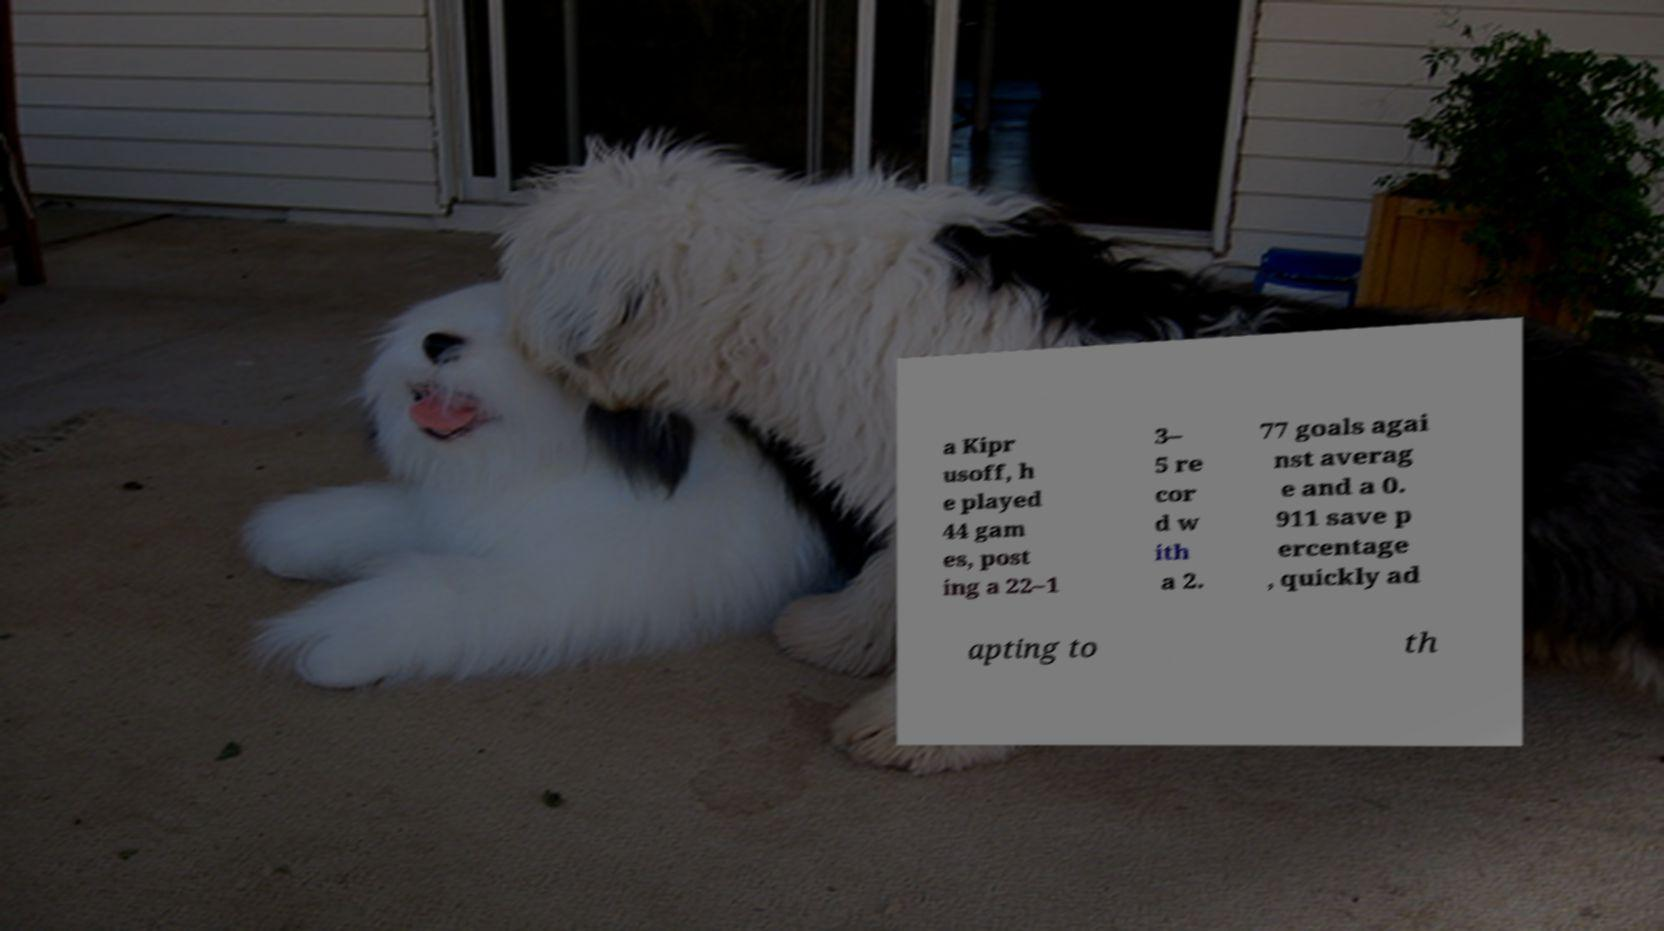Please identify and transcribe the text found in this image. a Kipr usoff, h e played 44 gam es, post ing a 22–1 3– 5 re cor d w ith a 2. 77 goals agai nst averag e and a 0. 911 save p ercentage , quickly ad apting to th 